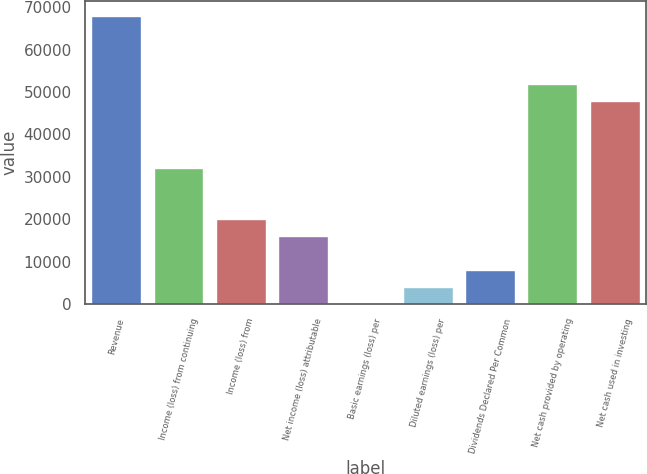Convert chart to OTSL. <chart><loc_0><loc_0><loc_500><loc_500><bar_chart><fcel>Revenue<fcel>Income (loss) from continuing<fcel>Income (loss) from<fcel>Net income (loss) attributable<fcel>Basic earnings (loss) per<fcel>Diluted earnings (loss) per<fcel>Dividends Declared Per Common<fcel>Net cash provided by operating<fcel>Net cash used in investing<nl><fcel>67967.6<fcel>31984.8<fcel>19990.6<fcel>15992.5<fcel>0.15<fcel>3998.24<fcel>7996.32<fcel>51975.2<fcel>47977.2<nl></chart> 